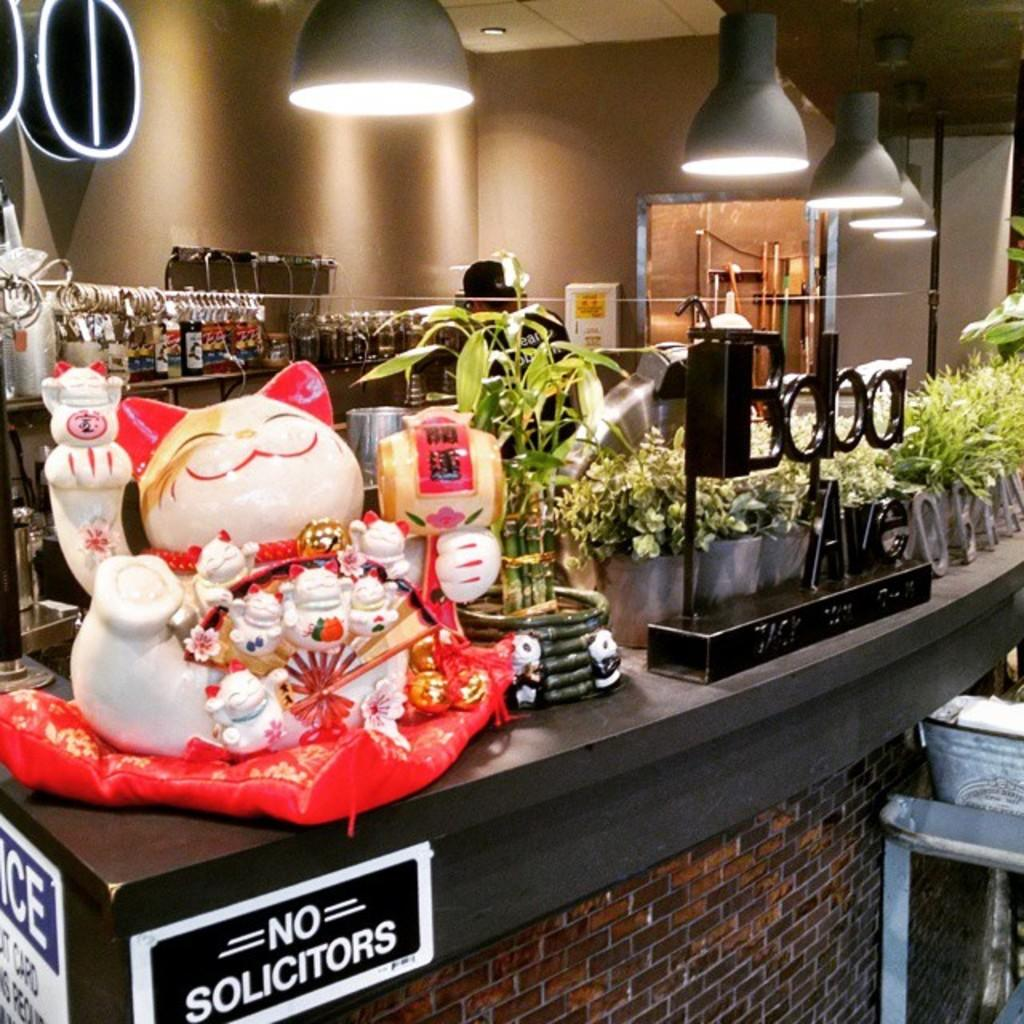Provide a one-sentence caption for the provided image. a table that has no solicitors on it. 